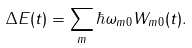<formula> <loc_0><loc_0><loc_500><loc_500>\Delta E ( t ) = \sum _ { m } \hbar { \omega } _ { m 0 } W _ { m 0 } ( t ) .</formula> 